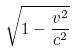<formula> <loc_0><loc_0><loc_500><loc_500>\sqrt { 1 - \frac { v ^ { 2 } } { c ^ { 2 } } }</formula> 